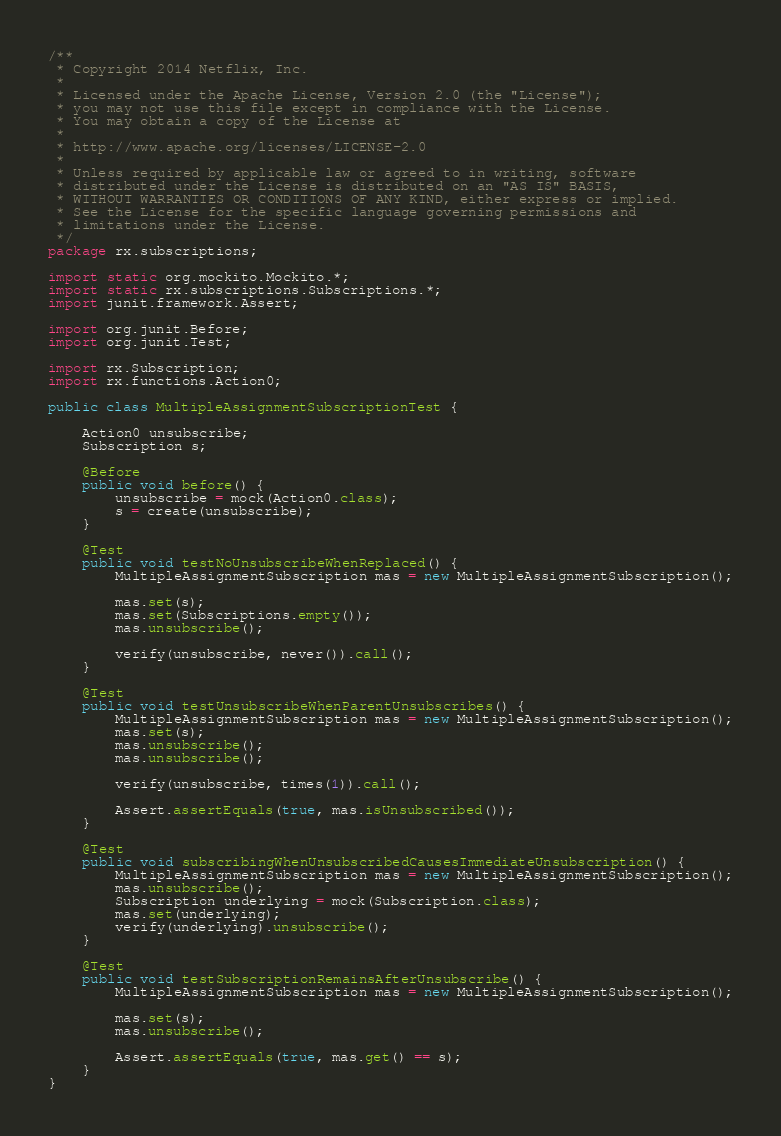Convert code to text. <code><loc_0><loc_0><loc_500><loc_500><_Java_>/**
 * Copyright 2014 Netflix, Inc.
 * 
 * Licensed under the Apache License, Version 2.0 (the "License");
 * you may not use this file except in compliance with the License.
 * You may obtain a copy of the License at
 * 
 * http://www.apache.org/licenses/LICENSE-2.0
 * 
 * Unless required by applicable law or agreed to in writing, software
 * distributed under the License is distributed on an "AS IS" BASIS,
 * WITHOUT WARRANTIES OR CONDITIONS OF ANY KIND, either express or implied.
 * See the License for the specific language governing permissions and
 * limitations under the License.
 */
package rx.subscriptions;

import static org.mockito.Mockito.*;
import static rx.subscriptions.Subscriptions.*;
import junit.framework.Assert;

import org.junit.Before;
import org.junit.Test;

import rx.Subscription;
import rx.functions.Action0;

public class MultipleAssignmentSubscriptionTest {

    Action0 unsubscribe;
    Subscription s;

    @Before
    public void before() {
        unsubscribe = mock(Action0.class);
        s = create(unsubscribe);
    }

    @Test
    public void testNoUnsubscribeWhenReplaced() {
        MultipleAssignmentSubscription mas = new MultipleAssignmentSubscription();

        mas.set(s);
        mas.set(Subscriptions.empty());
        mas.unsubscribe();

        verify(unsubscribe, never()).call();
    }

    @Test
    public void testUnsubscribeWhenParentUnsubscribes() {
        MultipleAssignmentSubscription mas = new MultipleAssignmentSubscription();
        mas.set(s);
        mas.unsubscribe();
        mas.unsubscribe();

        verify(unsubscribe, times(1)).call();

        Assert.assertEquals(true, mas.isUnsubscribed());
    }

    @Test
    public void subscribingWhenUnsubscribedCausesImmediateUnsubscription() {
        MultipleAssignmentSubscription mas = new MultipleAssignmentSubscription();
        mas.unsubscribe();
        Subscription underlying = mock(Subscription.class);
        mas.set(underlying);
        verify(underlying).unsubscribe();
    }

    @Test
    public void testSubscriptionRemainsAfterUnsubscribe() {
        MultipleAssignmentSubscription mas = new MultipleAssignmentSubscription();

        mas.set(s);
        mas.unsubscribe();

        Assert.assertEquals(true, mas.get() == s);
    }
}</code> 